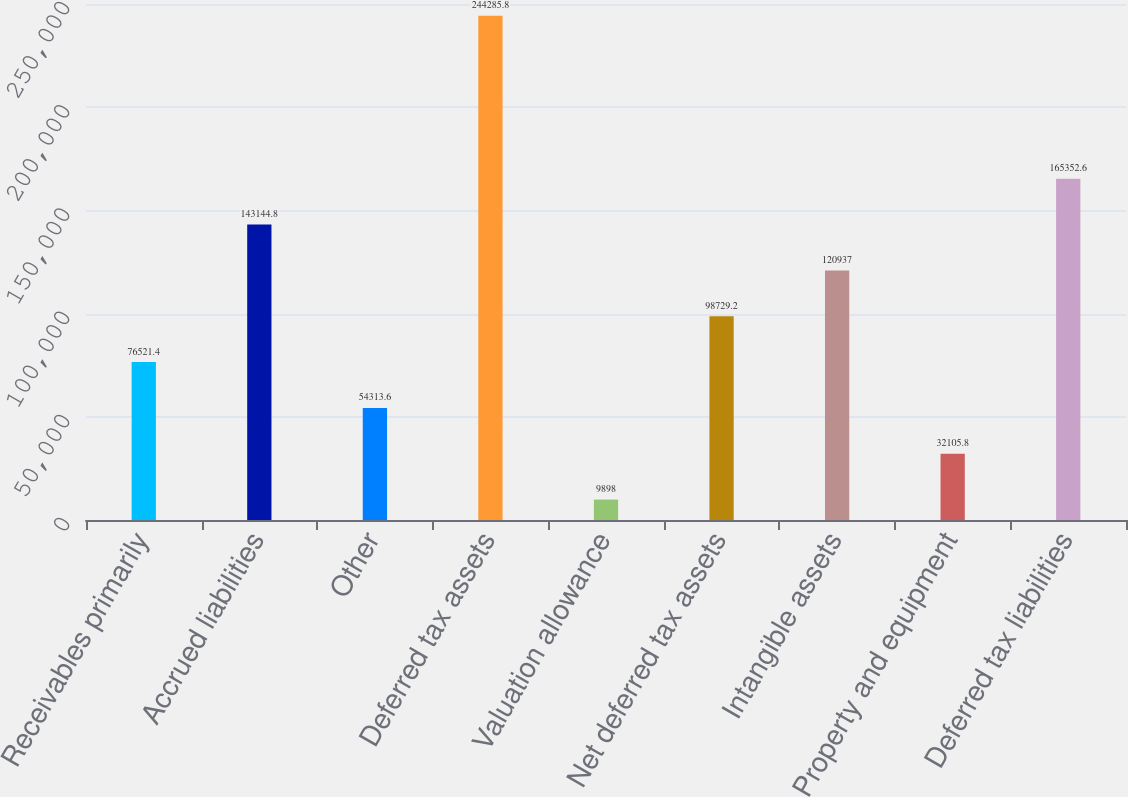Convert chart. <chart><loc_0><loc_0><loc_500><loc_500><bar_chart><fcel>Receivables primarily<fcel>Accrued liabilities<fcel>Other<fcel>Deferred tax assets<fcel>Valuation allowance<fcel>Net deferred tax assets<fcel>Intangible assets<fcel>Property and equipment<fcel>Deferred tax liabilities<nl><fcel>76521.4<fcel>143145<fcel>54313.6<fcel>244286<fcel>9898<fcel>98729.2<fcel>120937<fcel>32105.8<fcel>165353<nl></chart> 